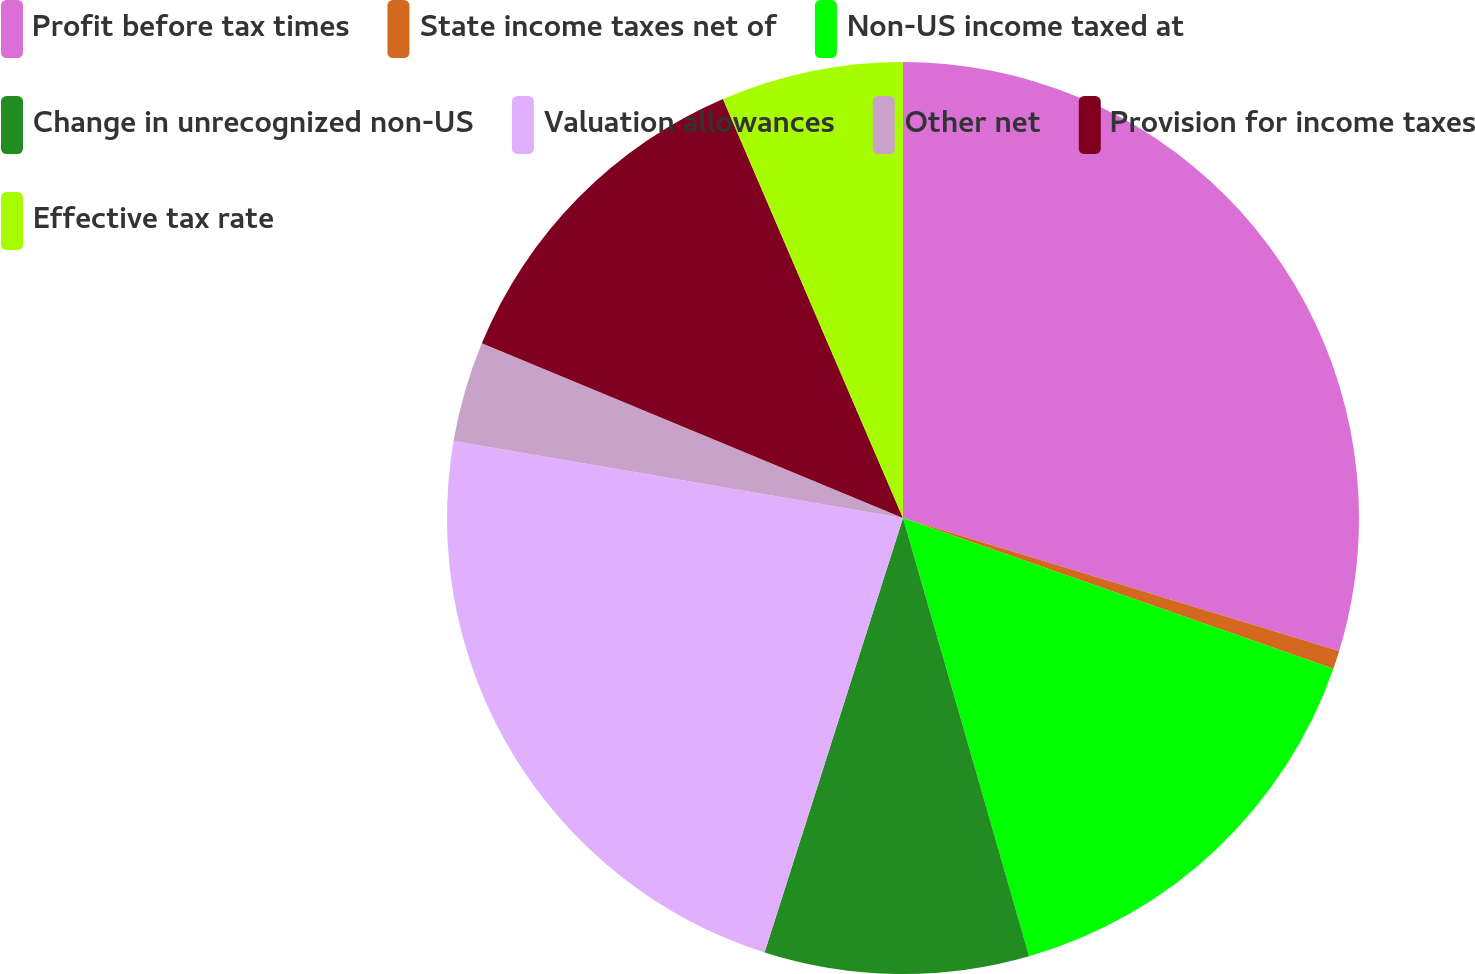<chart> <loc_0><loc_0><loc_500><loc_500><pie_chart><fcel>Profit before tax times<fcel>State income taxes net of<fcel>Non-US income taxed at<fcel>Change in unrecognized non-US<fcel>Valuation allowances<fcel>Other net<fcel>Provision for income taxes<fcel>Effective tax rate<nl><fcel>29.71%<fcel>0.65%<fcel>15.18%<fcel>9.37%<fcel>22.79%<fcel>3.56%<fcel>12.28%<fcel>6.46%<nl></chart> 